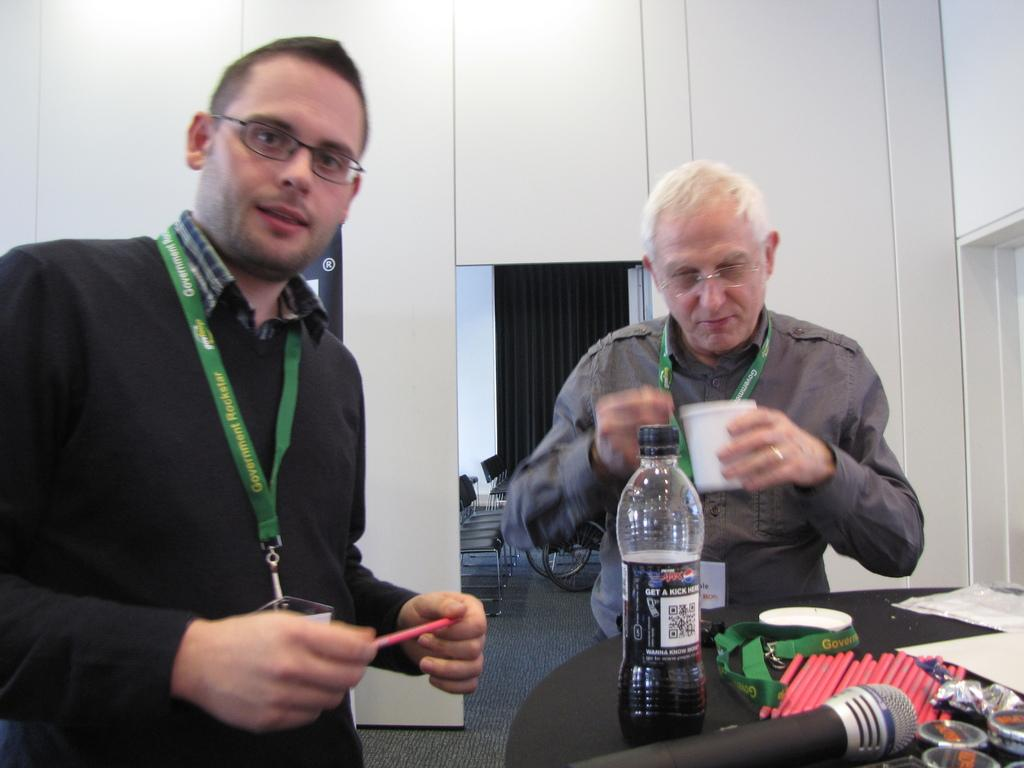How many people are standing in the image? There are two persons standing in the image. What is on the table in the image? There is a microphone, a green color tag, a bottle, pencils, and papers on the table. What is the purpose of the microphone on the table? The microphone on the table is likely used for amplifying sound during a presentation or speech. What can be seen in the background of the image? There are empty chairs and a wheel in the background. What page of the nation's constitution is being discussed in the image? There is no reference to a constitution or any discussion in the image. What is the significance of the fifth element in the image? There is no mention of any elements or numbers in the image. 